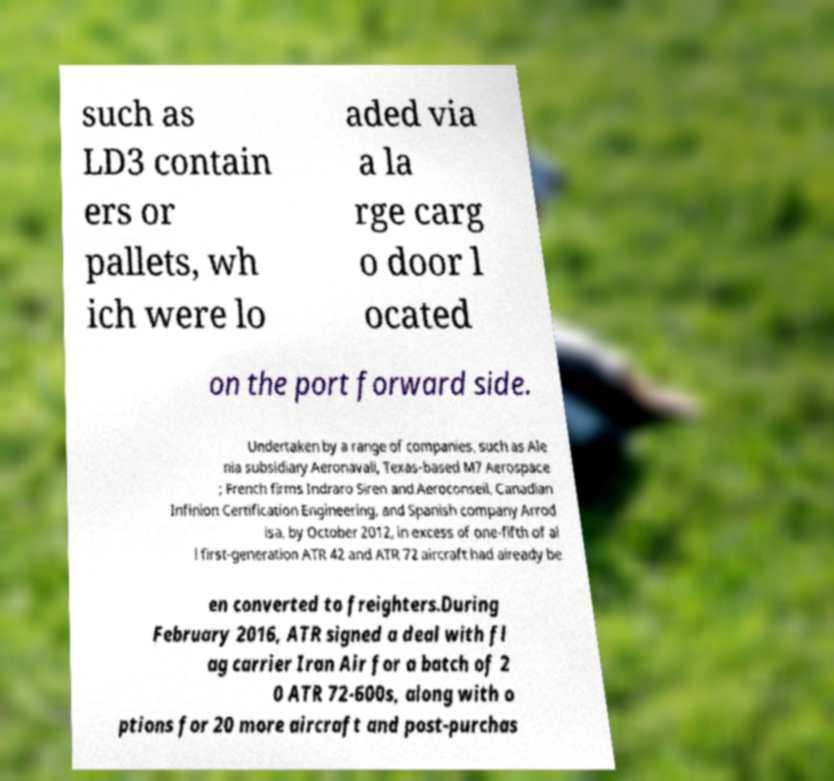Could you assist in decoding the text presented in this image and type it out clearly? such as LD3 contain ers or pallets, wh ich were lo aded via a la rge carg o door l ocated on the port forward side. Undertaken by a range of companies, such as Ale nia subsidiary Aeronavali, Texas-based M7 Aerospace ; French firms Indraro Siren and Aeroconseil, Canadian Infinion Certification Engineering, and Spanish company Arrod isa, by October 2012, in excess of one-fifth of al l first-generation ATR 42 and ATR 72 aircraft had already be en converted to freighters.During February 2016, ATR signed a deal with fl ag carrier Iran Air for a batch of 2 0 ATR 72-600s, along with o ptions for 20 more aircraft and post-purchas 